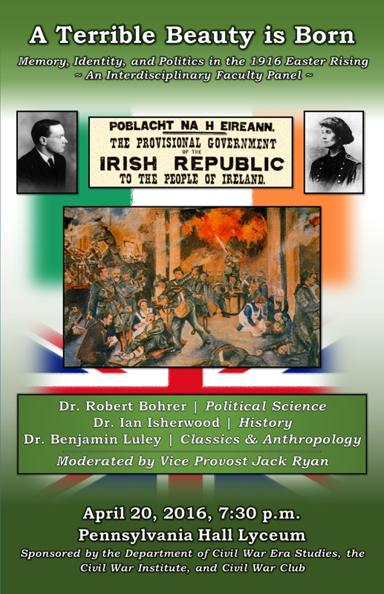When and where is the panel taking place? The faculty panel discussion is scheduled for April 20, 2016, starting at 7:30 p.m. It will be held in the Pennsylvania Hall Lyceum, offering a historic and fitting venue for discussing this monumental event in history. 